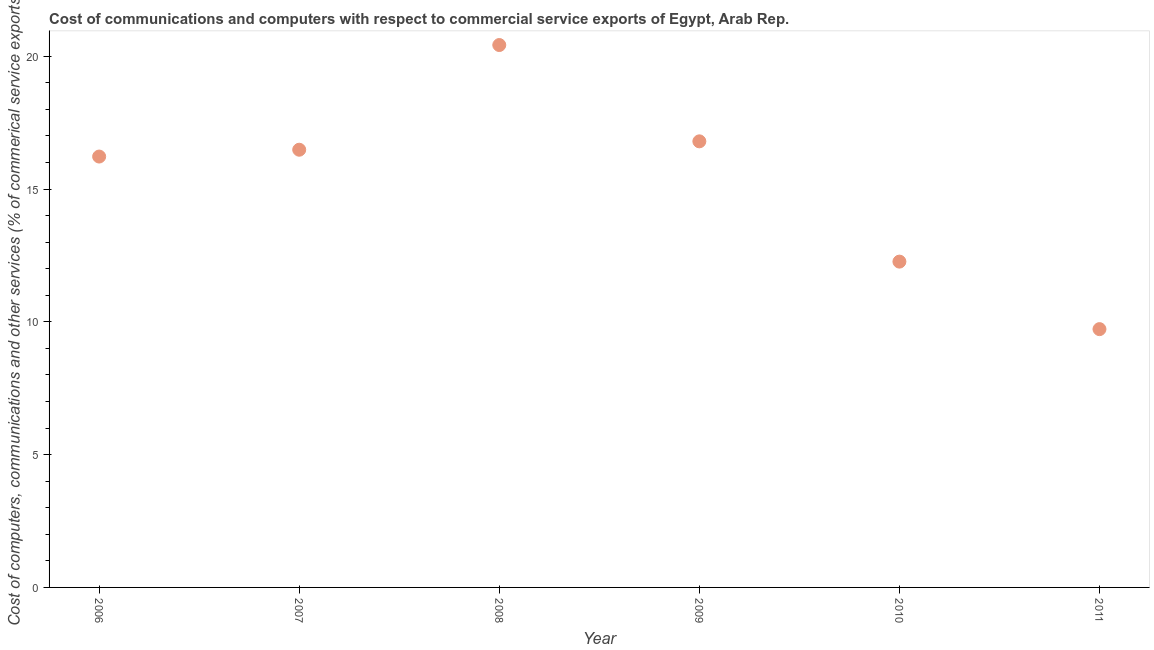What is the cost of communications in 2009?
Give a very brief answer. 16.79. Across all years, what is the maximum cost of communications?
Your answer should be compact. 20.42. Across all years, what is the minimum  computer and other services?
Your answer should be very brief. 9.72. In which year was the cost of communications maximum?
Offer a very short reply. 2008. In which year was the cost of communications minimum?
Offer a terse response. 2011. What is the sum of the cost of communications?
Offer a very short reply. 91.91. What is the difference between the cost of communications in 2006 and 2011?
Offer a very short reply. 6.5. What is the average  computer and other services per year?
Provide a short and direct response. 15.32. What is the median cost of communications?
Keep it short and to the point. 16.35. Do a majority of the years between 2007 and 2011 (inclusive) have  computer and other services greater than 4 %?
Ensure brevity in your answer.  Yes. What is the ratio of the cost of communications in 2006 to that in 2010?
Your answer should be compact. 1.32. Is the cost of communications in 2010 less than that in 2011?
Give a very brief answer. No. Is the difference between the  computer and other services in 2007 and 2008 greater than the difference between any two years?
Ensure brevity in your answer.  No. What is the difference between the highest and the second highest cost of communications?
Your answer should be very brief. 3.63. Is the sum of the cost of communications in 2006 and 2008 greater than the maximum cost of communications across all years?
Offer a very short reply. Yes. What is the difference between the highest and the lowest cost of communications?
Make the answer very short. 10.7. How many dotlines are there?
Your answer should be very brief. 1. How many years are there in the graph?
Offer a very short reply. 6. Does the graph contain grids?
Provide a short and direct response. No. What is the title of the graph?
Ensure brevity in your answer.  Cost of communications and computers with respect to commercial service exports of Egypt, Arab Rep. What is the label or title of the Y-axis?
Keep it short and to the point. Cost of computers, communications and other services (% of commerical service exports). What is the Cost of computers, communications and other services (% of commerical service exports) in 2006?
Make the answer very short. 16.22. What is the Cost of computers, communications and other services (% of commerical service exports) in 2007?
Offer a very short reply. 16.48. What is the Cost of computers, communications and other services (% of commerical service exports) in 2008?
Offer a terse response. 20.42. What is the Cost of computers, communications and other services (% of commerical service exports) in 2009?
Your response must be concise. 16.79. What is the Cost of computers, communications and other services (% of commerical service exports) in 2010?
Your answer should be very brief. 12.27. What is the Cost of computers, communications and other services (% of commerical service exports) in 2011?
Keep it short and to the point. 9.72. What is the difference between the Cost of computers, communications and other services (% of commerical service exports) in 2006 and 2007?
Your response must be concise. -0.26. What is the difference between the Cost of computers, communications and other services (% of commerical service exports) in 2006 and 2008?
Make the answer very short. -4.2. What is the difference between the Cost of computers, communications and other services (% of commerical service exports) in 2006 and 2009?
Provide a short and direct response. -0.57. What is the difference between the Cost of computers, communications and other services (% of commerical service exports) in 2006 and 2010?
Provide a short and direct response. 3.96. What is the difference between the Cost of computers, communications and other services (% of commerical service exports) in 2006 and 2011?
Give a very brief answer. 6.5. What is the difference between the Cost of computers, communications and other services (% of commerical service exports) in 2007 and 2008?
Make the answer very short. -3.94. What is the difference between the Cost of computers, communications and other services (% of commerical service exports) in 2007 and 2009?
Your answer should be very brief. -0.32. What is the difference between the Cost of computers, communications and other services (% of commerical service exports) in 2007 and 2010?
Provide a short and direct response. 4.21. What is the difference between the Cost of computers, communications and other services (% of commerical service exports) in 2007 and 2011?
Ensure brevity in your answer.  6.75. What is the difference between the Cost of computers, communications and other services (% of commerical service exports) in 2008 and 2009?
Offer a terse response. 3.63. What is the difference between the Cost of computers, communications and other services (% of commerical service exports) in 2008 and 2010?
Give a very brief answer. 8.15. What is the difference between the Cost of computers, communications and other services (% of commerical service exports) in 2008 and 2011?
Offer a terse response. 10.7. What is the difference between the Cost of computers, communications and other services (% of commerical service exports) in 2009 and 2010?
Your response must be concise. 4.53. What is the difference between the Cost of computers, communications and other services (% of commerical service exports) in 2009 and 2011?
Ensure brevity in your answer.  7.07. What is the difference between the Cost of computers, communications and other services (% of commerical service exports) in 2010 and 2011?
Make the answer very short. 2.54. What is the ratio of the Cost of computers, communications and other services (% of commerical service exports) in 2006 to that in 2007?
Offer a very short reply. 0.98. What is the ratio of the Cost of computers, communications and other services (% of commerical service exports) in 2006 to that in 2008?
Ensure brevity in your answer.  0.79. What is the ratio of the Cost of computers, communications and other services (% of commerical service exports) in 2006 to that in 2009?
Your response must be concise. 0.97. What is the ratio of the Cost of computers, communications and other services (% of commerical service exports) in 2006 to that in 2010?
Ensure brevity in your answer.  1.32. What is the ratio of the Cost of computers, communications and other services (% of commerical service exports) in 2006 to that in 2011?
Your answer should be compact. 1.67. What is the ratio of the Cost of computers, communications and other services (% of commerical service exports) in 2007 to that in 2008?
Your response must be concise. 0.81. What is the ratio of the Cost of computers, communications and other services (% of commerical service exports) in 2007 to that in 2010?
Ensure brevity in your answer.  1.34. What is the ratio of the Cost of computers, communications and other services (% of commerical service exports) in 2007 to that in 2011?
Provide a succinct answer. 1.7. What is the ratio of the Cost of computers, communications and other services (% of commerical service exports) in 2008 to that in 2009?
Offer a terse response. 1.22. What is the ratio of the Cost of computers, communications and other services (% of commerical service exports) in 2008 to that in 2010?
Give a very brief answer. 1.67. What is the ratio of the Cost of computers, communications and other services (% of commerical service exports) in 2009 to that in 2010?
Your response must be concise. 1.37. What is the ratio of the Cost of computers, communications and other services (% of commerical service exports) in 2009 to that in 2011?
Your answer should be very brief. 1.73. What is the ratio of the Cost of computers, communications and other services (% of commerical service exports) in 2010 to that in 2011?
Ensure brevity in your answer.  1.26. 